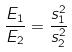<formula> <loc_0><loc_0><loc_500><loc_500>\frac { E _ { 1 } } { E _ { 2 } } = \frac { s _ { 1 } ^ { 2 } } { s _ { 2 } ^ { 2 } }</formula> 